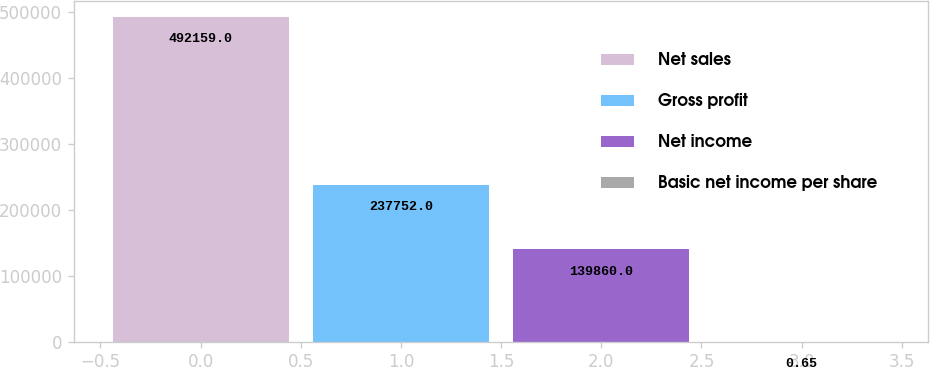Convert chart. <chart><loc_0><loc_0><loc_500><loc_500><bar_chart><fcel>Net sales<fcel>Gross profit<fcel>Net income<fcel>Basic net income per share<nl><fcel>492159<fcel>237752<fcel>139860<fcel>0.65<nl></chart> 